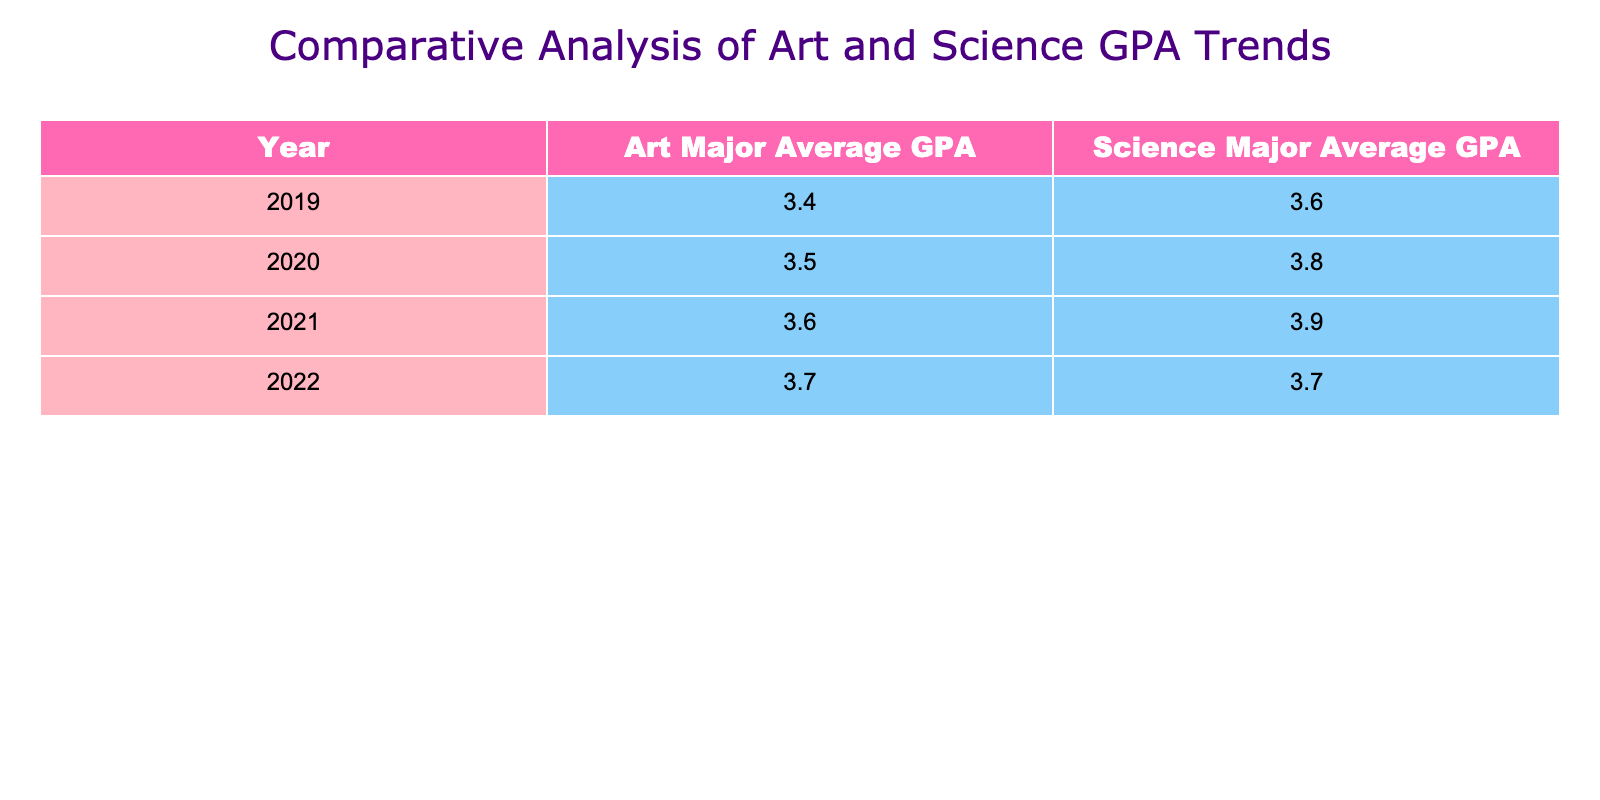What is the average GPA for art majors in 2021? The table shows that the average GPA for art majors in 2021 is explicitly listed as 3.6.
Answer: 3.6 What was the highest GPA achieved by science majors in the provided years? Looking at the Science Major Average GPA column, the highest value is 3.9, which occurred in 2021.
Answer: 3.9 In which year did art majors show the most significant increase in their average GPA compared to the previous year? By examining the Art Major Average GPA, we see that the increase from 3.5 in 2020 to 3.6 in 2021 is 0.1, and the increase from 3.6 in 2021 to 3.7 in 2022 is also 0.1. The only year with a larger increase is from 3.4 in 2019 to 3.5 in 2020, which is also 0.1. Therefore, there is no year with a larger increase compared to the others; they are all the same.
Answer: There is no year with a more significant increase What was the overall change in GPA for science majors from 2019 to 2022? The Science Major Average GPA in 2019 is 3.6 and in 2022 is 3.7. To find the change, we calculate 3.7 - 3.6 = 0.1, indicating a slight increase.
Answer: 0.1 Is it true that in 2020, art majors had a higher average GPA than science majors? In 2020, the average GPA for art majors was 3.5, while for science majors, it was 3.8. Since 3.5 is less than 3.8, the statement is false.
Answer: False What was the average GPA for both majors in 2022, and how do they compare? In 2022, the average GPA for art majors was 3.7, and for science majors, it was 3.7 as well. Both are the same, showing equal performance that year.
Answer: They are equal at 3.7 Which major had a consistently higher GPA over the four years? Evaluating the table, the Science Major Average GPA starts higher than the Art Major Average GPA and remains equal to it only in 2022. Thus, science majors had a consistently higher GPA over three out of the four years.
Answer: Science majors What is the difference between the art and science major average GPAs in 2021? In 2021, the average GPA for art majors was 3.6 and for science majors was 3.9. To find the difference, subtract the art GPA from the science GPA: 3.9 - 3.6 = 0.3.
Answer: 0.3 